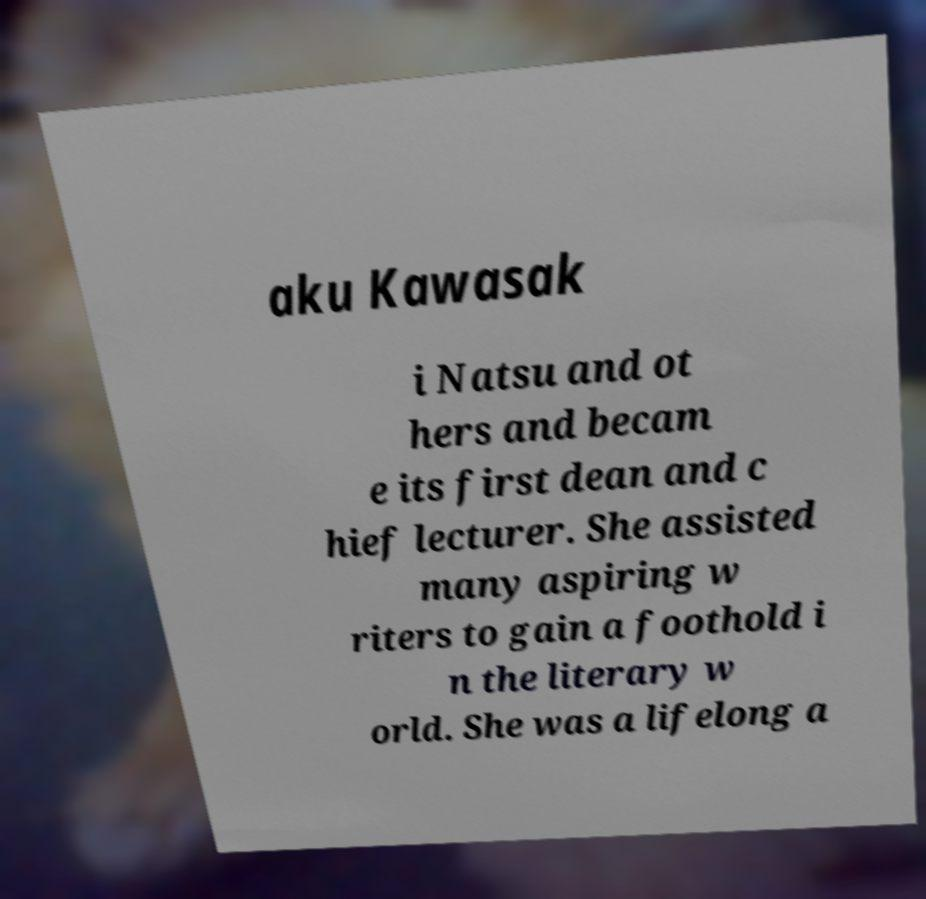Could you extract and type out the text from this image? aku Kawasak i Natsu and ot hers and becam e its first dean and c hief lecturer. She assisted many aspiring w riters to gain a foothold i n the literary w orld. She was a lifelong a 